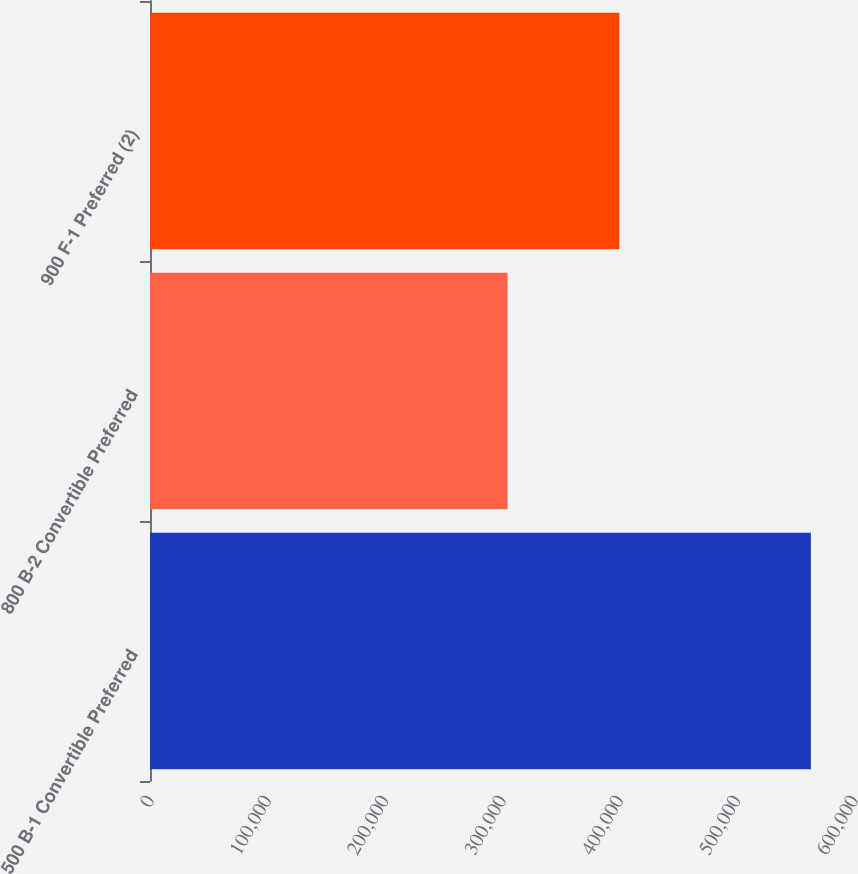Convert chart. <chart><loc_0><loc_0><loc_500><loc_500><bar_chart><fcel>500 B-1 Convertible Preferred<fcel>800 B-2 Convertible Preferred<fcel>900 F-1 Preferred (2)<nl><fcel>563263<fcel>304761<fcel>400000<nl></chart> 